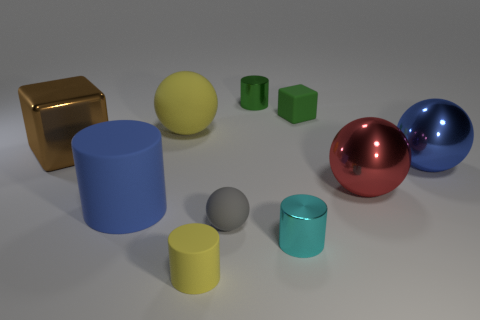What textures are present among the objects? The objects exhibit a variety of textures. The brown block and the two spheres on the right have reflective, glossy textures, suggesting a metallic or polished surface. The cylinders and the cube have matte surfaces, indicative of a non-reflective material like plastic or painted wood. 